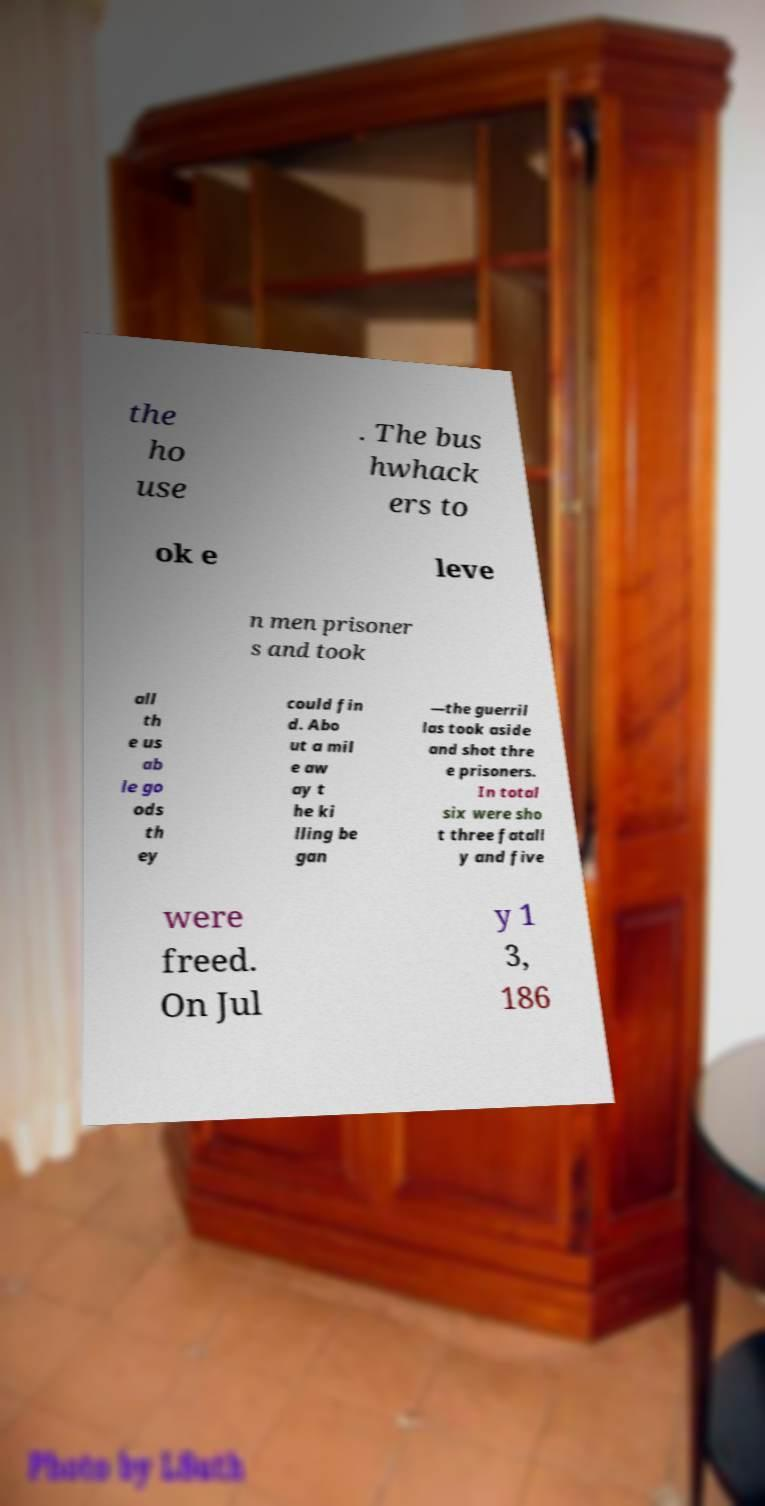What messages or text are displayed in this image? I need them in a readable, typed format. the ho use . The bus hwhack ers to ok e leve n men prisoner s and took all th e us ab le go ods th ey could fin d. Abo ut a mil e aw ay t he ki lling be gan —the guerril las took aside and shot thre e prisoners. In total six were sho t three fatall y and five were freed. On Jul y 1 3, 186 